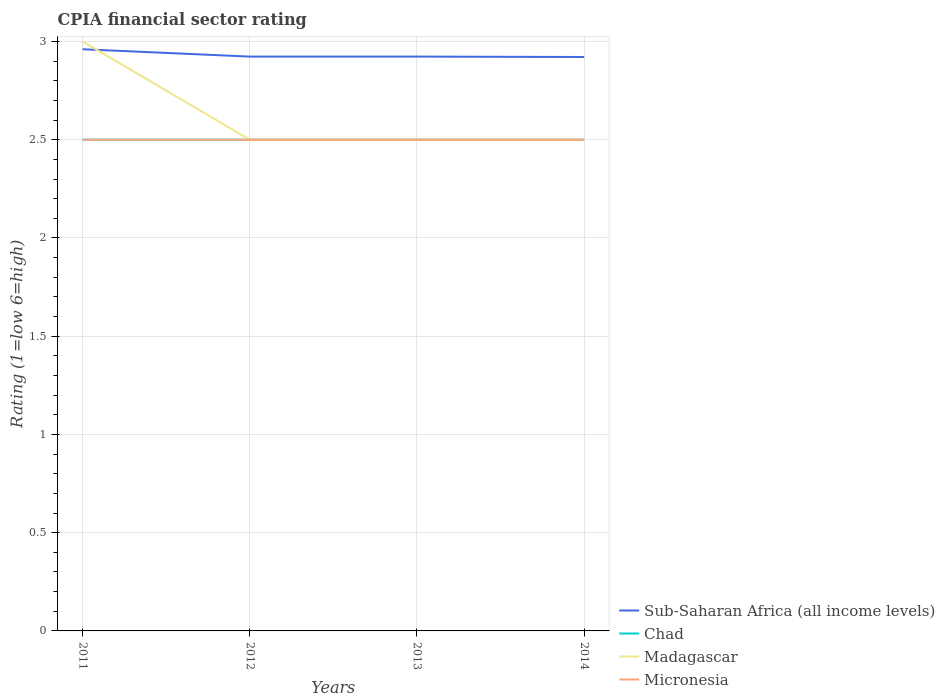Does the line corresponding to Chad intersect with the line corresponding to Micronesia?
Your answer should be compact. Yes. In which year was the CPIA rating in Micronesia maximum?
Offer a terse response. 2011. What is the difference between the highest and the second highest CPIA rating in Sub-Saharan Africa (all income levels)?
Your answer should be compact. 0.04. What is the difference between the highest and the lowest CPIA rating in Sub-Saharan Africa (all income levels)?
Your answer should be compact. 1. Are the values on the major ticks of Y-axis written in scientific E-notation?
Your answer should be very brief. No. Does the graph contain grids?
Offer a terse response. Yes. Where does the legend appear in the graph?
Give a very brief answer. Bottom right. What is the title of the graph?
Provide a short and direct response. CPIA financial sector rating. Does "Tunisia" appear as one of the legend labels in the graph?
Provide a succinct answer. No. What is the Rating (1=low 6=high) of Sub-Saharan Africa (all income levels) in 2011?
Provide a short and direct response. 2.96. What is the Rating (1=low 6=high) of Madagascar in 2011?
Provide a succinct answer. 3. What is the Rating (1=low 6=high) of Sub-Saharan Africa (all income levels) in 2012?
Your response must be concise. 2.92. What is the Rating (1=low 6=high) in Chad in 2012?
Offer a very short reply. 2.5. What is the Rating (1=low 6=high) in Sub-Saharan Africa (all income levels) in 2013?
Make the answer very short. 2.92. What is the Rating (1=low 6=high) in Madagascar in 2013?
Ensure brevity in your answer.  2.5. What is the Rating (1=low 6=high) in Sub-Saharan Africa (all income levels) in 2014?
Offer a terse response. 2.92. What is the Rating (1=low 6=high) of Micronesia in 2014?
Provide a succinct answer. 2.5. Across all years, what is the maximum Rating (1=low 6=high) of Sub-Saharan Africa (all income levels)?
Make the answer very short. 2.96. Across all years, what is the maximum Rating (1=low 6=high) in Chad?
Your answer should be compact. 2.5. Across all years, what is the maximum Rating (1=low 6=high) in Madagascar?
Your answer should be compact. 3. Across all years, what is the maximum Rating (1=low 6=high) in Micronesia?
Provide a succinct answer. 2.5. Across all years, what is the minimum Rating (1=low 6=high) in Sub-Saharan Africa (all income levels)?
Offer a very short reply. 2.92. Across all years, what is the minimum Rating (1=low 6=high) in Micronesia?
Your answer should be compact. 2.5. What is the total Rating (1=low 6=high) of Sub-Saharan Africa (all income levels) in the graph?
Offer a very short reply. 11.73. What is the total Rating (1=low 6=high) in Chad in the graph?
Your answer should be compact. 10. What is the difference between the Rating (1=low 6=high) of Sub-Saharan Africa (all income levels) in 2011 and that in 2012?
Make the answer very short. 0.04. What is the difference between the Rating (1=low 6=high) of Madagascar in 2011 and that in 2012?
Provide a succinct answer. 0.5. What is the difference between the Rating (1=low 6=high) in Micronesia in 2011 and that in 2012?
Your answer should be compact. 0. What is the difference between the Rating (1=low 6=high) in Sub-Saharan Africa (all income levels) in 2011 and that in 2013?
Your response must be concise. 0.04. What is the difference between the Rating (1=low 6=high) of Chad in 2011 and that in 2013?
Offer a terse response. 0. What is the difference between the Rating (1=low 6=high) of Madagascar in 2011 and that in 2013?
Your response must be concise. 0.5. What is the difference between the Rating (1=low 6=high) of Micronesia in 2011 and that in 2013?
Keep it short and to the point. 0. What is the difference between the Rating (1=low 6=high) of Sub-Saharan Africa (all income levels) in 2011 and that in 2014?
Make the answer very short. 0.04. What is the difference between the Rating (1=low 6=high) in Micronesia in 2011 and that in 2014?
Offer a terse response. 0. What is the difference between the Rating (1=low 6=high) in Sub-Saharan Africa (all income levels) in 2012 and that in 2013?
Make the answer very short. 0. What is the difference between the Rating (1=low 6=high) in Chad in 2012 and that in 2013?
Your response must be concise. 0. What is the difference between the Rating (1=low 6=high) of Sub-Saharan Africa (all income levels) in 2012 and that in 2014?
Keep it short and to the point. 0. What is the difference between the Rating (1=low 6=high) of Chad in 2012 and that in 2014?
Give a very brief answer. 0. What is the difference between the Rating (1=low 6=high) of Madagascar in 2012 and that in 2014?
Your response must be concise. 0. What is the difference between the Rating (1=low 6=high) in Micronesia in 2012 and that in 2014?
Ensure brevity in your answer.  0. What is the difference between the Rating (1=low 6=high) in Sub-Saharan Africa (all income levels) in 2013 and that in 2014?
Make the answer very short. 0. What is the difference between the Rating (1=low 6=high) in Chad in 2013 and that in 2014?
Your response must be concise. 0. What is the difference between the Rating (1=low 6=high) of Micronesia in 2013 and that in 2014?
Provide a succinct answer. 0. What is the difference between the Rating (1=low 6=high) of Sub-Saharan Africa (all income levels) in 2011 and the Rating (1=low 6=high) of Chad in 2012?
Ensure brevity in your answer.  0.46. What is the difference between the Rating (1=low 6=high) of Sub-Saharan Africa (all income levels) in 2011 and the Rating (1=low 6=high) of Madagascar in 2012?
Offer a very short reply. 0.46. What is the difference between the Rating (1=low 6=high) of Sub-Saharan Africa (all income levels) in 2011 and the Rating (1=low 6=high) of Micronesia in 2012?
Give a very brief answer. 0.46. What is the difference between the Rating (1=low 6=high) of Chad in 2011 and the Rating (1=low 6=high) of Madagascar in 2012?
Keep it short and to the point. 0. What is the difference between the Rating (1=low 6=high) of Chad in 2011 and the Rating (1=low 6=high) of Micronesia in 2012?
Give a very brief answer. 0. What is the difference between the Rating (1=low 6=high) in Sub-Saharan Africa (all income levels) in 2011 and the Rating (1=low 6=high) in Chad in 2013?
Your response must be concise. 0.46. What is the difference between the Rating (1=low 6=high) in Sub-Saharan Africa (all income levels) in 2011 and the Rating (1=low 6=high) in Madagascar in 2013?
Give a very brief answer. 0.46. What is the difference between the Rating (1=low 6=high) in Sub-Saharan Africa (all income levels) in 2011 and the Rating (1=low 6=high) in Micronesia in 2013?
Make the answer very short. 0.46. What is the difference between the Rating (1=low 6=high) in Chad in 2011 and the Rating (1=low 6=high) in Madagascar in 2013?
Provide a short and direct response. 0. What is the difference between the Rating (1=low 6=high) in Chad in 2011 and the Rating (1=low 6=high) in Micronesia in 2013?
Give a very brief answer. 0. What is the difference between the Rating (1=low 6=high) of Madagascar in 2011 and the Rating (1=low 6=high) of Micronesia in 2013?
Your response must be concise. 0.5. What is the difference between the Rating (1=low 6=high) of Sub-Saharan Africa (all income levels) in 2011 and the Rating (1=low 6=high) of Chad in 2014?
Your answer should be very brief. 0.46. What is the difference between the Rating (1=low 6=high) of Sub-Saharan Africa (all income levels) in 2011 and the Rating (1=low 6=high) of Madagascar in 2014?
Give a very brief answer. 0.46. What is the difference between the Rating (1=low 6=high) in Sub-Saharan Africa (all income levels) in 2011 and the Rating (1=low 6=high) in Micronesia in 2014?
Provide a succinct answer. 0.46. What is the difference between the Rating (1=low 6=high) in Chad in 2011 and the Rating (1=low 6=high) in Madagascar in 2014?
Give a very brief answer. 0. What is the difference between the Rating (1=low 6=high) of Chad in 2011 and the Rating (1=low 6=high) of Micronesia in 2014?
Give a very brief answer. 0. What is the difference between the Rating (1=low 6=high) of Madagascar in 2011 and the Rating (1=low 6=high) of Micronesia in 2014?
Your answer should be compact. 0.5. What is the difference between the Rating (1=low 6=high) in Sub-Saharan Africa (all income levels) in 2012 and the Rating (1=low 6=high) in Chad in 2013?
Provide a succinct answer. 0.42. What is the difference between the Rating (1=low 6=high) in Sub-Saharan Africa (all income levels) in 2012 and the Rating (1=low 6=high) in Madagascar in 2013?
Provide a succinct answer. 0.42. What is the difference between the Rating (1=low 6=high) in Sub-Saharan Africa (all income levels) in 2012 and the Rating (1=low 6=high) in Micronesia in 2013?
Keep it short and to the point. 0.42. What is the difference between the Rating (1=low 6=high) in Madagascar in 2012 and the Rating (1=low 6=high) in Micronesia in 2013?
Your response must be concise. 0. What is the difference between the Rating (1=low 6=high) of Sub-Saharan Africa (all income levels) in 2012 and the Rating (1=low 6=high) of Chad in 2014?
Ensure brevity in your answer.  0.42. What is the difference between the Rating (1=low 6=high) of Sub-Saharan Africa (all income levels) in 2012 and the Rating (1=low 6=high) of Madagascar in 2014?
Your answer should be compact. 0.42. What is the difference between the Rating (1=low 6=high) of Sub-Saharan Africa (all income levels) in 2012 and the Rating (1=low 6=high) of Micronesia in 2014?
Offer a terse response. 0.42. What is the difference between the Rating (1=low 6=high) in Sub-Saharan Africa (all income levels) in 2013 and the Rating (1=low 6=high) in Chad in 2014?
Make the answer very short. 0.42. What is the difference between the Rating (1=low 6=high) in Sub-Saharan Africa (all income levels) in 2013 and the Rating (1=low 6=high) in Madagascar in 2014?
Your response must be concise. 0.42. What is the difference between the Rating (1=low 6=high) in Sub-Saharan Africa (all income levels) in 2013 and the Rating (1=low 6=high) in Micronesia in 2014?
Keep it short and to the point. 0.42. What is the difference between the Rating (1=low 6=high) of Chad in 2013 and the Rating (1=low 6=high) of Madagascar in 2014?
Offer a very short reply. 0. What is the difference between the Rating (1=low 6=high) of Chad in 2013 and the Rating (1=low 6=high) of Micronesia in 2014?
Your answer should be compact. 0. What is the average Rating (1=low 6=high) in Sub-Saharan Africa (all income levels) per year?
Offer a very short reply. 2.93. What is the average Rating (1=low 6=high) in Madagascar per year?
Your response must be concise. 2.62. In the year 2011, what is the difference between the Rating (1=low 6=high) in Sub-Saharan Africa (all income levels) and Rating (1=low 6=high) in Chad?
Give a very brief answer. 0.46. In the year 2011, what is the difference between the Rating (1=low 6=high) of Sub-Saharan Africa (all income levels) and Rating (1=low 6=high) of Madagascar?
Provide a succinct answer. -0.04. In the year 2011, what is the difference between the Rating (1=low 6=high) in Sub-Saharan Africa (all income levels) and Rating (1=low 6=high) in Micronesia?
Ensure brevity in your answer.  0.46. In the year 2011, what is the difference between the Rating (1=low 6=high) of Chad and Rating (1=low 6=high) of Madagascar?
Ensure brevity in your answer.  -0.5. In the year 2011, what is the difference between the Rating (1=low 6=high) in Chad and Rating (1=low 6=high) in Micronesia?
Your response must be concise. 0. In the year 2011, what is the difference between the Rating (1=low 6=high) of Madagascar and Rating (1=low 6=high) of Micronesia?
Provide a succinct answer. 0.5. In the year 2012, what is the difference between the Rating (1=low 6=high) in Sub-Saharan Africa (all income levels) and Rating (1=low 6=high) in Chad?
Your response must be concise. 0.42. In the year 2012, what is the difference between the Rating (1=low 6=high) of Sub-Saharan Africa (all income levels) and Rating (1=low 6=high) of Madagascar?
Provide a short and direct response. 0.42. In the year 2012, what is the difference between the Rating (1=low 6=high) in Sub-Saharan Africa (all income levels) and Rating (1=low 6=high) in Micronesia?
Your answer should be very brief. 0.42. In the year 2013, what is the difference between the Rating (1=low 6=high) in Sub-Saharan Africa (all income levels) and Rating (1=low 6=high) in Chad?
Provide a succinct answer. 0.42. In the year 2013, what is the difference between the Rating (1=low 6=high) of Sub-Saharan Africa (all income levels) and Rating (1=low 6=high) of Madagascar?
Offer a very short reply. 0.42. In the year 2013, what is the difference between the Rating (1=low 6=high) in Sub-Saharan Africa (all income levels) and Rating (1=low 6=high) in Micronesia?
Your answer should be compact. 0.42. In the year 2013, what is the difference between the Rating (1=low 6=high) in Chad and Rating (1=low 6=high) in Micronesia?
Offer a very short reply. 0. In the year 2014, what is the difference between the Rating (1=low 6=high) of Sub-Saharan Africa (all income levels) and Rating (1=low 6=high) of Chad?
Provide a short and direct response. 0.42. In the year 2014, what is the difference between the Rating (1=low 6=high) of Sub-Saharan Africa (all income levels) and Rating (1=low 6=high) of Madagascar?
Offer a terse response. 0.42. In the year 2014, what is the difference between the Rating (1=low 6=high) of Sub-Saharan Africa (all income levels) and Rating (1=low 6=high) of Micronesia?
Ensure brevity in your answer.  0.42. In the year 2014, what is the difference between the Rating (1=low 6=high) of Chad and Rating (1=low 6=high) of Micronesia?
Provide a short and direct response. 0. In the year 2014, what is the difference between the Rating (1=low 6=high) of Madagascar and Rating (1=low 6=high) of Micronesia?
Offer a very short reply. 0. What is the ratio of the Rating (1=low 6=high) in Sub-Saharan Africa (all income levels) in 2011 to that in 2012?
Your answer should be compact. 1.01. What is the ratio of the Rating (1=low 6=high) of Micronesia in 2011 to that in 2012?
Your answer should be very brief. 1. What is the ratio of the Rating (1=low 6=high) in Sub-Saharan Africa (all income levels) in 2011 to that in 2013?
Ensure brevity in your answer.  1.01. What is the ratio of the Rating (1=low 6=high) of Chad in 2011 to that in 2013?
Your answer should be very brief. 1. What is the ratio of the Rating (1=low 6=high) in Sub-Saharan Africa (all income levels) in 2011 to that in 2014?
Give a very brief answer. 1.01. What is the ratio of the Rating (1=low 6=high) in Chad in 2011 to that in 2014?
Ensure brevity in your answer.  1. What is the ratio of the Rating (1=low 6=high) of Madagascar in 2011 to that in 2014?
Give a very brief answer. 1.2. What is the ratio of the Rating (1=low 6=high) in Chad in 2012 to that in 2013?
Your response must be concise. 1. What is the ratio of the Rating (1=low 6=high) in Micronesia in 2012 to that in 2013?
Make the answer very short. 1. What is the ratio of the Rating (1=low 6=high) in Madagascar in 2012 to that in 2014?
Give a very brief answer. 1. What is the difference between the highest and the second highest Rating (1=low 6=high) of Sub-Saharan Africa (all income levels)?
Provide a succinct answer. 0.04. What is the difference between the highest and the second highest Rating (1=low 6=high) of Chad?
Your answer should be very brief. 0. What is the difference between the highest and the second highest Rating (1=low 6=high) of Madagascar?
Your answer should be very brief. 0.5. What is the difference between the highest and the lowest Rating (1=low 6=high) in Sub-Saharan Africa (all income levels)?
Make the answer very short. 0.04. What is the difference between the highest and the lowest Rating (1=low 6=high) in Madagascar?
Your response must be concise. 0.5. 